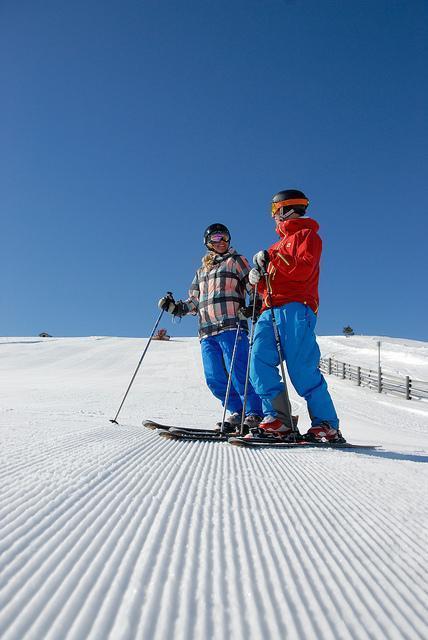How many skiers on this hill?
Give a very brief answer. 2. How many people are in the picture?
Give a very brief answer. 2. How many chairs are in the picture?
Give a very brief answer. 0. 